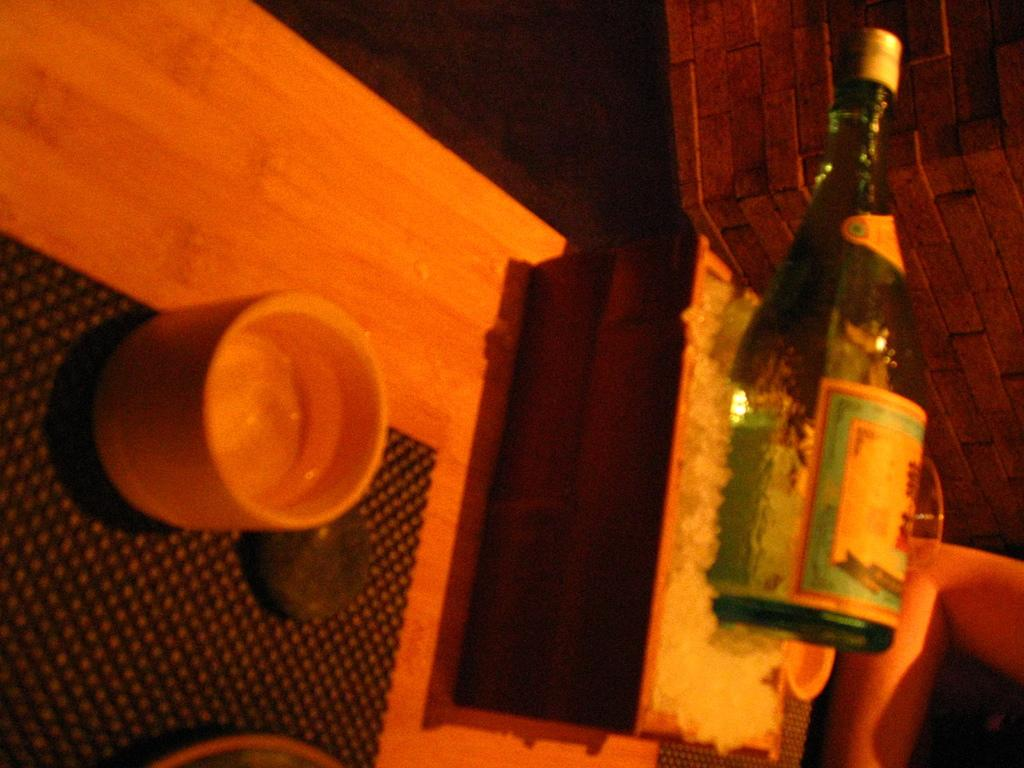What is the main object in the image? There is a table in the image. What is on the table? The table contains a cup and a box with ice cubes. What is the purpose of the box with ice cubes? The box with ice cubes is likely used to keep the contents cold. What else is on the box with ice cubes? There is a bottle on the box with ice cubes. What is visible behind the table? There is a wall behind the table. What type of rhythm can be heard coming from the jail in the image? There is no jail present in the image, and therefore no rhythm can be heard. 